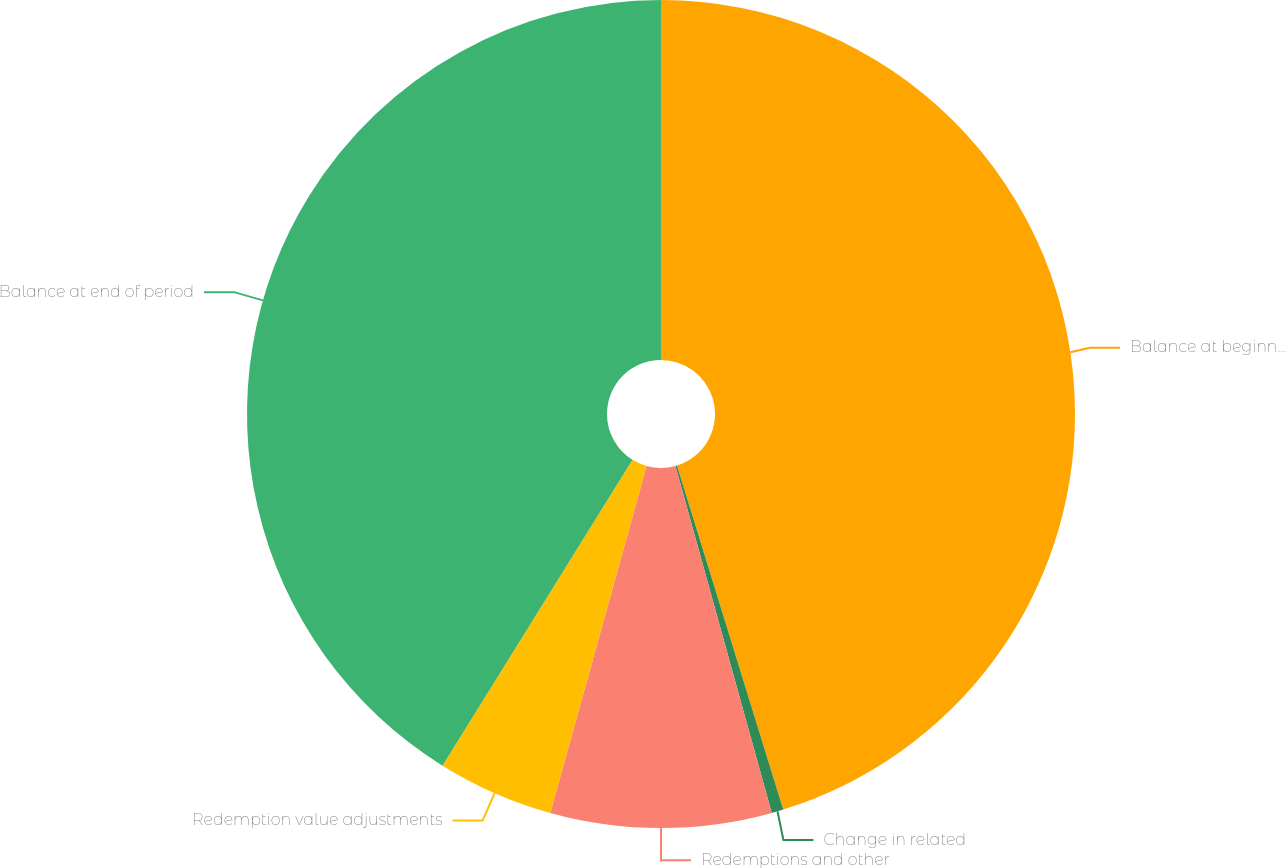<chart> <loc_0><loc_0><loc_500><loc_500><pie_chart><fcel>Balance at beginning of period<fcel>Change in related<fcel>Redemptions and other<fcel>Redemption value adjustments<fcel>Balance at end of period<nl><fcel>45.23%<fcel>0.46%<fcel>8.62%<fcel>4.54%<fcel>41.15%<nl></chart> 